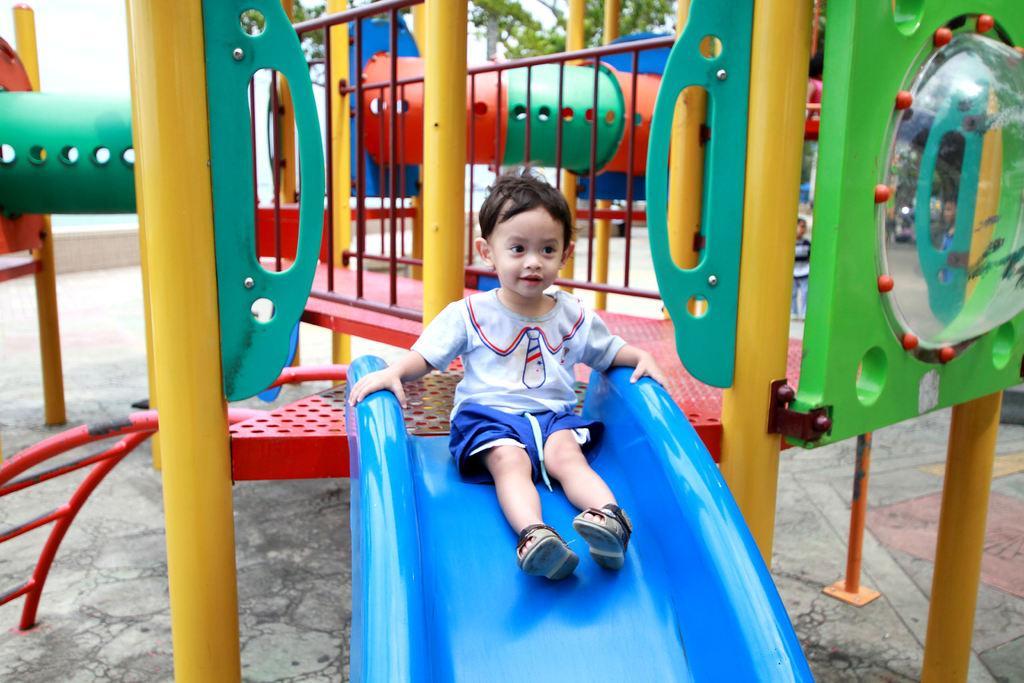Can you describe this image briefly? This picture is clicked outside. In the center there is a kid wearing white color t-shirt and sitting on a blue color slide. In the background we can see many number of slides and a tree. 